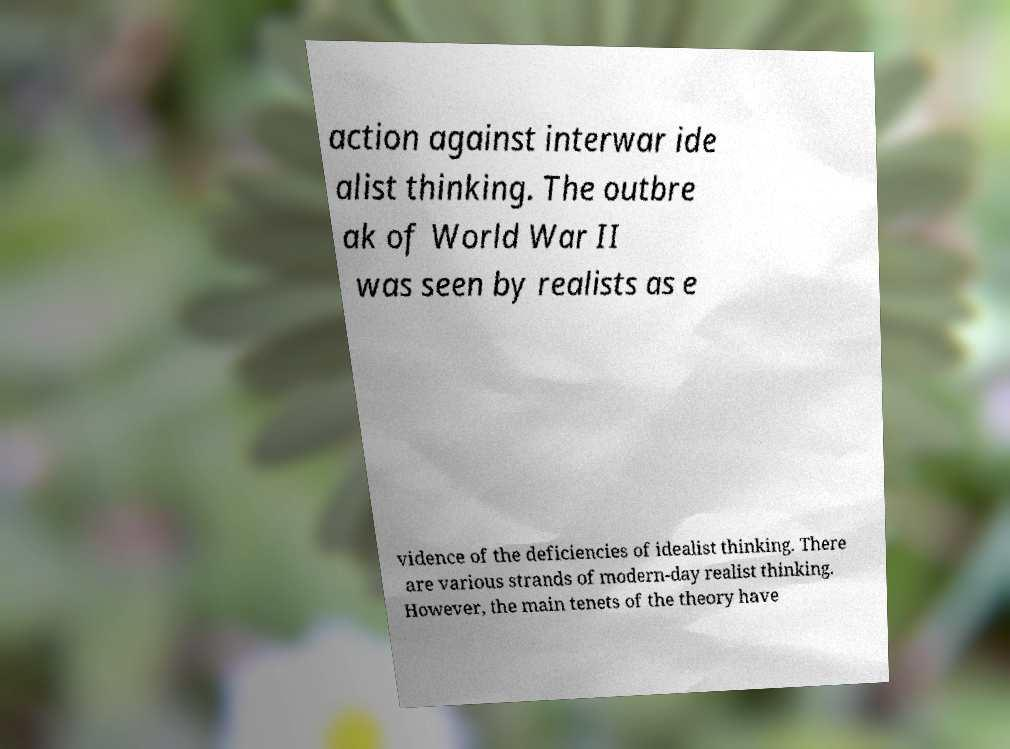Can you tell me more about the historical context of the text in the image? Certainly! The text on the paper discusses a shift in philosophical thinking around the time of World War II. During the interwar period, idealist thinking was prevalent, which typically involves a belief in the potential for human progress and peace through international cooperation and the rule of law. Realists challenged this view, arguing that international relations are governed by self-interest and the struggle for power. The outbreak of WWII appeared to validate realist theory over idealism, demonstrating that conflict and power dynamics are central to understanding international relationships. 